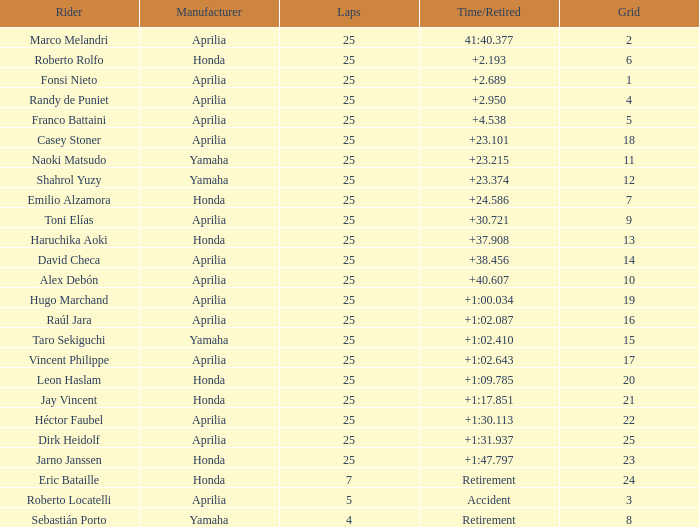Which producer has experienced accidents that are either time-related or retired? Aprilia. 